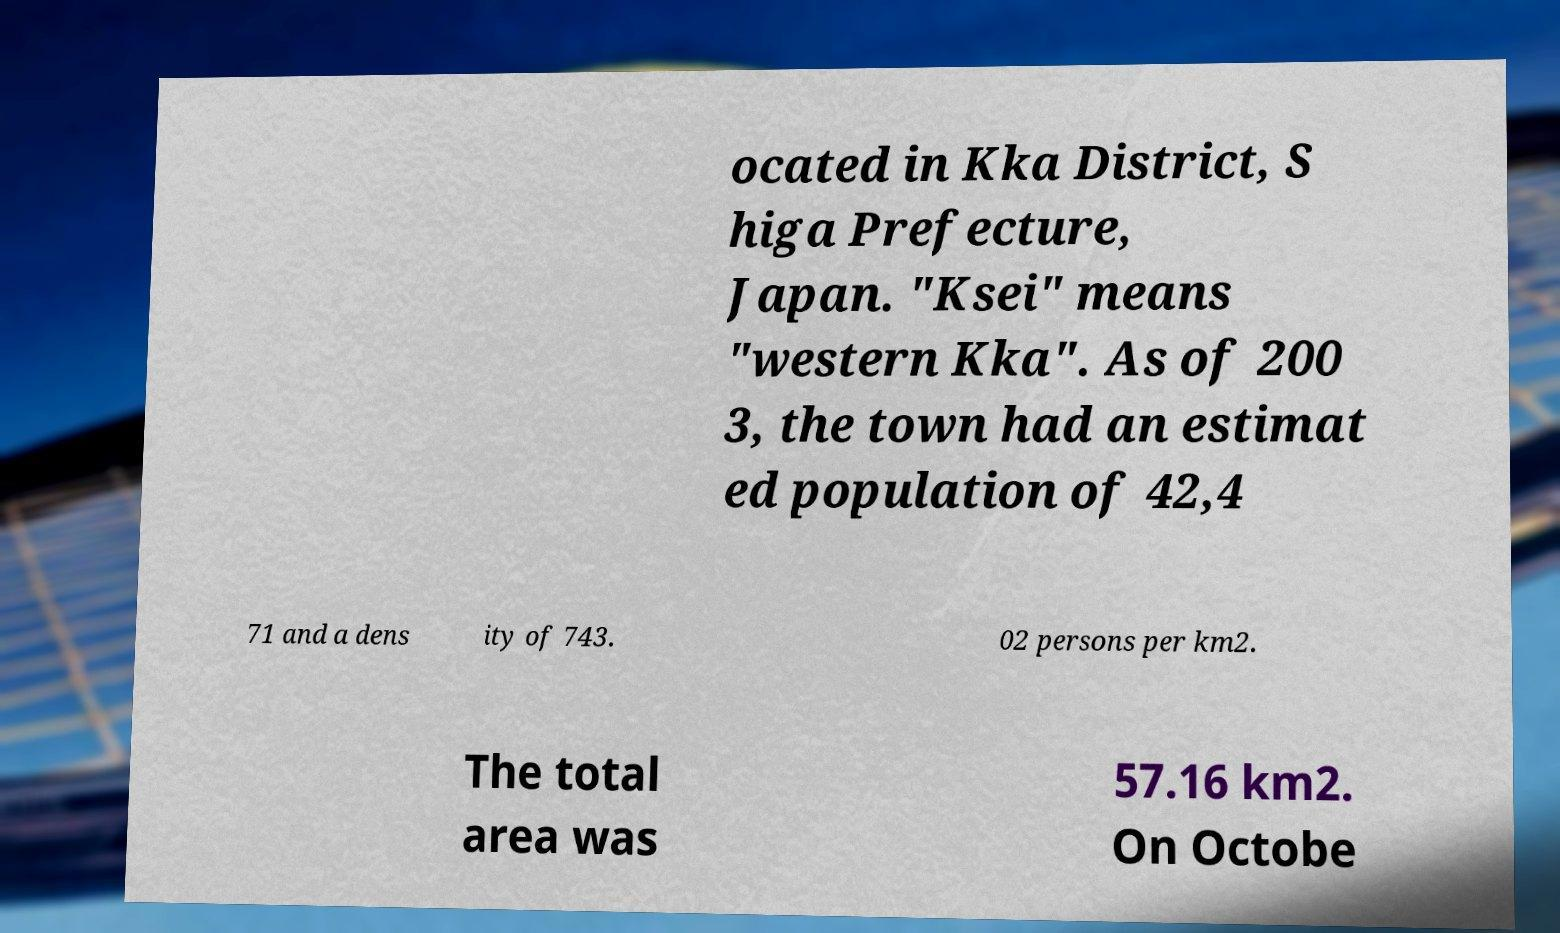Please identify and transcribe the text found in this image. ocated in Kka District, S higa Prefecture, Japan. "Ksei" means "western Kka". As of 200 3, the town had an estimat ed population of 42,4 71 and a dens ity of 743. 02 persons per km2. The total area was 57.16 km2. On Octobe 